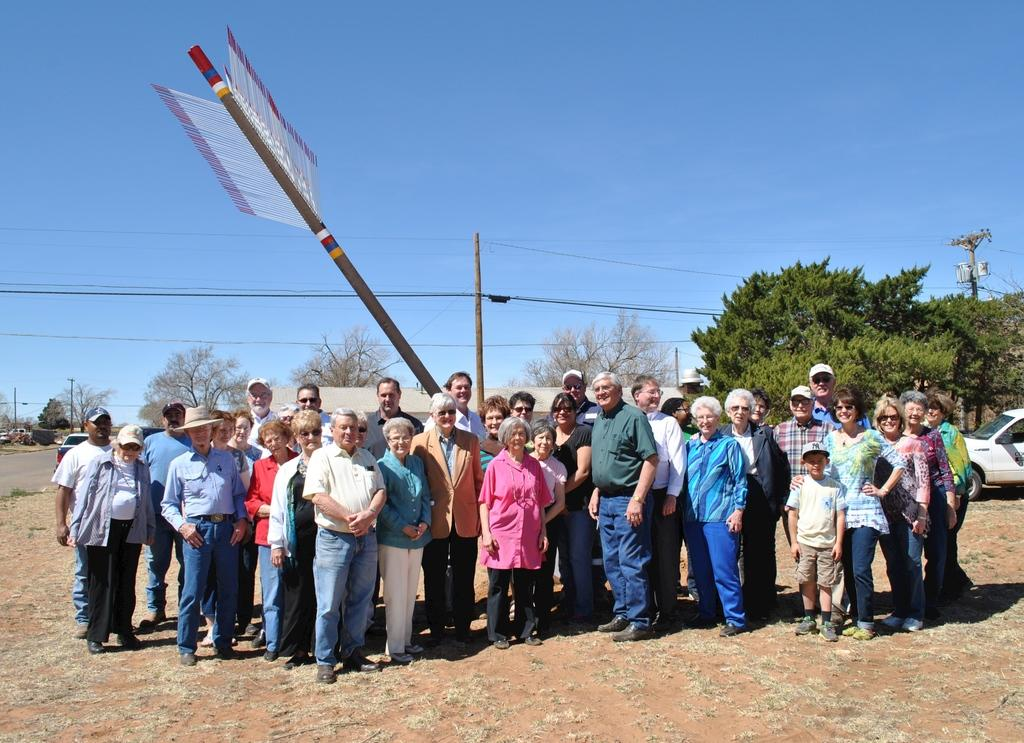How many people can be seen in the image? There are people in the image, but the exact number is not specified. What type of surface is visible on the ground in the image? The ground is visible in the image, and it appears to be grass. What other natural elements are present in the image? There are trees in the image. What type of structures can be seen in the image? Poles are present in the image. Are there any additional objects visible on the ground? Yes, there are objects on the ground in the image. What type of vehicles are present in the image? Vehicles are present in the image, but the specific type is not mentioned. What part of the environment is visible above the ground? The sky is visible in the image. How many pigs can be seen holding onto the engine in the image? There are no pigs or engines present in the image. What type of grip do the people have on the wires in the image? There is no mention of people holding onto wires in the image, and therefore no grip can be observed. 